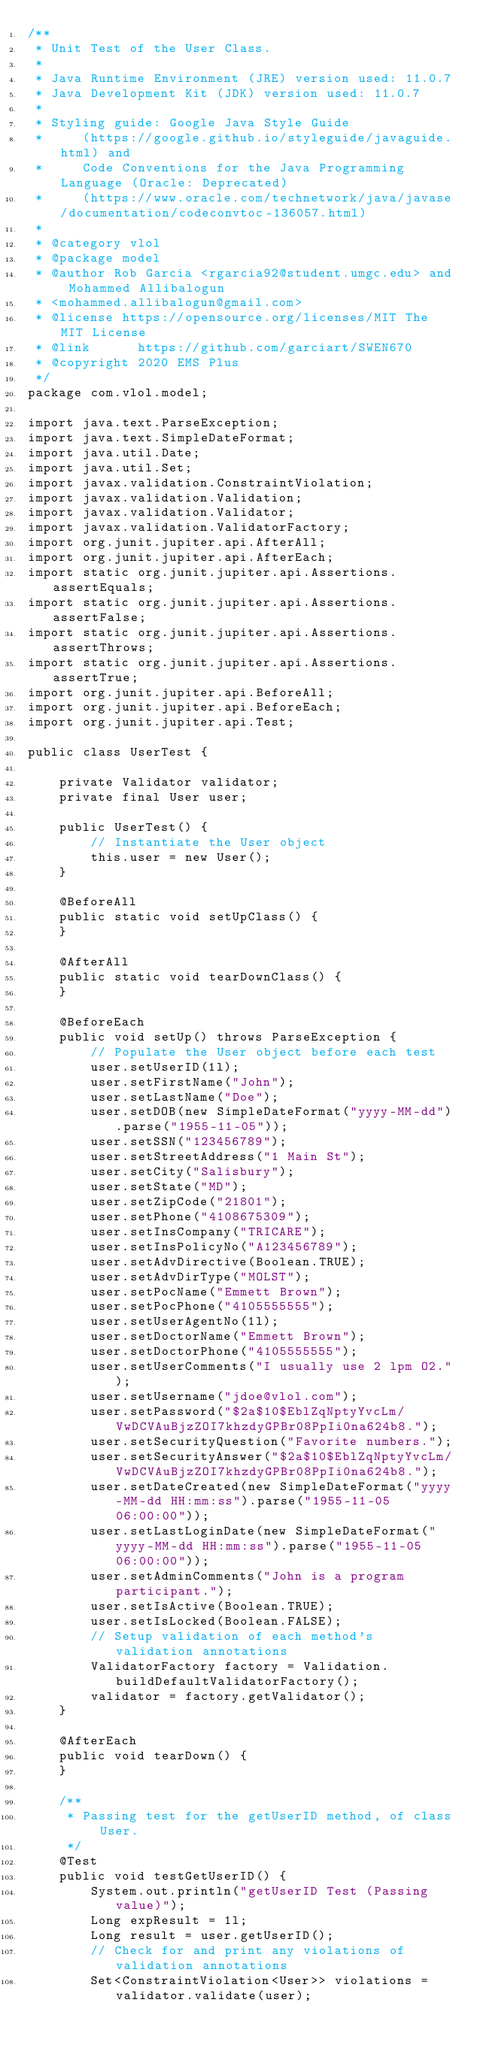Convert code to text. <code><loc_0><loc_0><loc_500><loc_500><_Java_>/**
 * Unit Test of the User Class.
 *
 * Java Runtime Environment (JRE) version used: 11.0.7
 * Java Development Kit (JDK) version used: 11.0.7
 *
 * Styling guide: Google Java Style Guide
 *     (https://google.github.io/styleguide/javaguide.html) and
 *     Code Conventions for the Java Programming Language (Oracle: Deprecated)
 *     (https://www.oracle.com/technetwork/java/javase/documentation/codeconvtoc-136057.html)
 *
 * @category vlol
 * @package model
 * @author Rob Garcia <rgarcia92@student.umgc.edu> and Mohammed Allibalogun
 * <mohammed.allibalogun@gmail.com>
 * @license https://opensource.org/licenses/MIT The MIT License
 * @link      https://github.com/garciart/SWEN670
 * @copyright 2020 EMS Plus
 */
package com.vlol.model;

import java.text.ParseException;
import java.text.SimpleDateFormat;
import java.util.Date;
import java.util.Set;
import javax.validation.ConstraintViolation;
import javax.validation.Validation;
import javax.validation.Validator;
import javax.validation.ValidatorFactory;
import org.junit.jupiter.api.AfterAll;
import org.junit.jupiter.api.AfterEach;
import static org.junit.jupiter.api.Assertions.assertEquals;
import static org.junit.jupiter.api.Assertions.assertFalse;
import static org.junit.jupiter.api.Assertions.assertThrows;
import static org.junit.jupiter.api.Assertions.assertTrue;
import org.junit.jupiter.api.BeforeAll;
import org.junit.jupiter.api.BeforeEach;
import org.junit.jupiter.api.Test;

public class UserTest {

    private Validator validator;
    private final User user;

    public UserTest() {
        // Instantiate the User object
        this.user = new User();
    }

    @BeforeAll
    public static void setUpClass() {
    }

    @AfterAll
    public static void tearDownClass() {
    }

    @BeforeEach
    public void setUp() throws ParseException {
        // Populate the User object before each test
        user.setUserID(1l);
        user.setFirstName("John");
        user.setLastName("Doe");
        user.setDOB(new SimpleDateFormat("yyyy-MM-dd").parse("1955-11-05"));
        user.setSSN("123456789");
        user.setStreetAddress("1 Main St");
        user.setCity("Salisbury");
        user.setState("MD");
        user.setZipCode("21801");
        user.setPhone("4108675309");
        user.setInsCompany("TRICARE");
        user.setInsPolicyNo("A123456789");
        user.setAdvDirective(Boolean.TRUE);
        user.setAdvDirType("MOLST");
        user.setPocName("Emmett Brown");
        user.setPocPhone("4105555555");
        user.setUserAgentNo(1l);
        user.setDoctorName("Emmett Brown");
        user.setDoctorPhone("4105555555");
        user.setUserComments("I usually use 2 lpm O2.");
        user.setUsername("jdoe@vlol.com");
        user.setPassword("$2a$10$EblZqNptyYvcLm/VwDCVAuBjzZOI7khzdyGPBr08PpIi0na624b8.");
        user.setSecurityQuestion("Favorite numbers.");
        user.setSecurityAnswer("$2a$10$EblZqNptyYvcLm/VwDCVAuBjzZOI7khzdyGPBr08PpIi0na624b8.");
        user.setDateCreated(new SimpleDateFormat("yyyy-MM-dd HH:mm:ss").parse("1955-11-05 06:00:00"));
        user.setLastLoginDate(new SimpleDateFormat("yyyy-MM-dd HH:mm:ss").parse("1955-11-05 06:00:00"));
        user.setAdminComments("John is a program participant.");
        user.setIsActive(Boolean.TRUE);
        user.setIsLocked(Boolean.FALSE);
        // Setup validation of each method's validation annotations
        ValidatorFactory factory = Validation.buildDefaultValidatorFactory();
        validator = factory.getValidator();
    }

    @AfterEach
    public void tearDown() {
    }

    /**
     * Passing test for the getUserID method, of class User.
     */
    @Test
    public void testGetUserID() {
        System.out.println("getUserID Test (Passing value)");
        Long expResult = 1l;
        Long result = user.getUserID();
        // Check for and print any violations of validation annotations
        Set<ConstraintViolation<User>> violations = validator.validate(user);</code> 